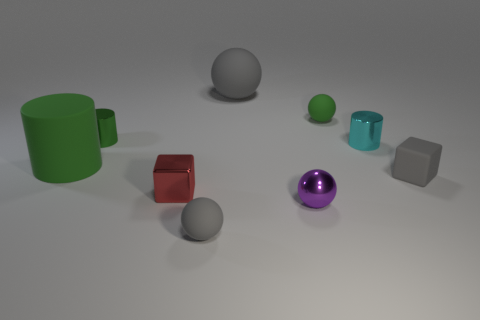Subtract all red spheres. Subtract all blue blocks. How many spheres are left? 4 Add 1 small gray blocks. How many objects exist? 10 Subtract all blocks. How many objects are left? 7 Add 3 gray objects. How many gray objects are left? 6 Add 1 small green cylinders. How many small green cylinders exist? 2 Subtract 0 blue cylinders. How many objects are left? 9 Subtract all small red objects. Subtract all small gray cubes. How many objects are left? 7 